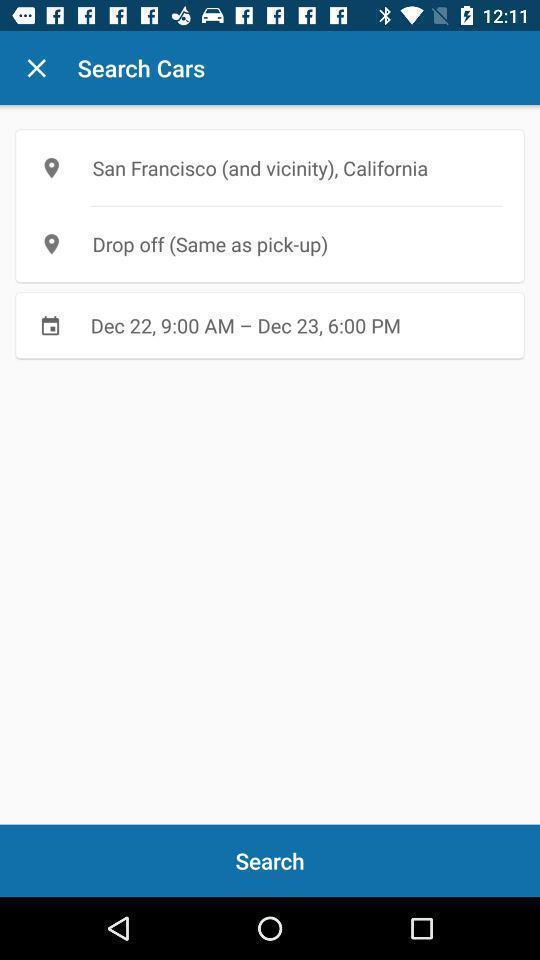Give me a summary of this screen capture. Search result displayed for travel bookings app. 